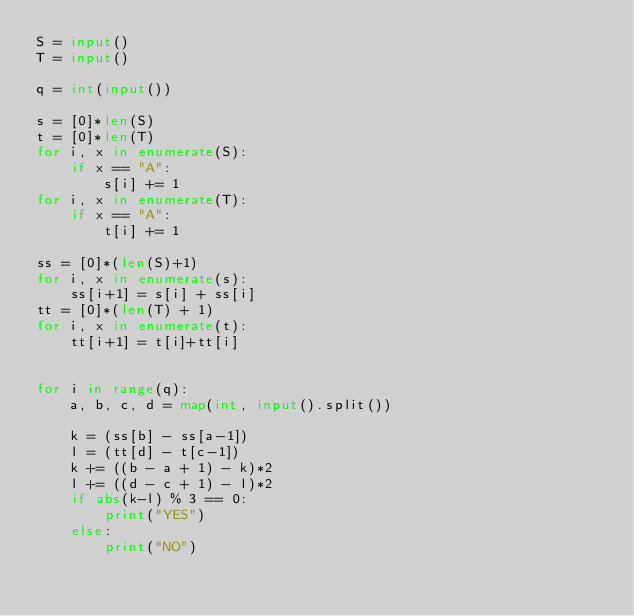Convert code to text. <code><loc_0><loc_0><loc_500><loc_500><_Python_>S = input()
T = input()

q = int(input())

s = [0]*len(S)
t = [0]*len(T)
for i, x in enumerate(S):
    if x == "A":
        s[i] += 1
for i, x in enumerate(T):
    if x == "A":
        t[i] += 1

ss = [0]*(len(S)+1)
for i, x in enumerate(s):
    ss[i+1] = s[i] + ss[i]
tt = [0]*(len(T) + 1)
for i, x in enumerate(t):
    tt[i+1] = t[i]+tt[i]


for i in range(q):
    a, b, c, d = map(int, input().split())

    k = (ss[b] - ss[a-1])
    l = (tt[d] - t[c-1])
    k += ((b - a + 1) - k)*2
    l += ((d - c + 1) - l)*2
    if abs(k-l) % 3 == 0:
        print("YES")
    else:
        print("NO")
</code> 